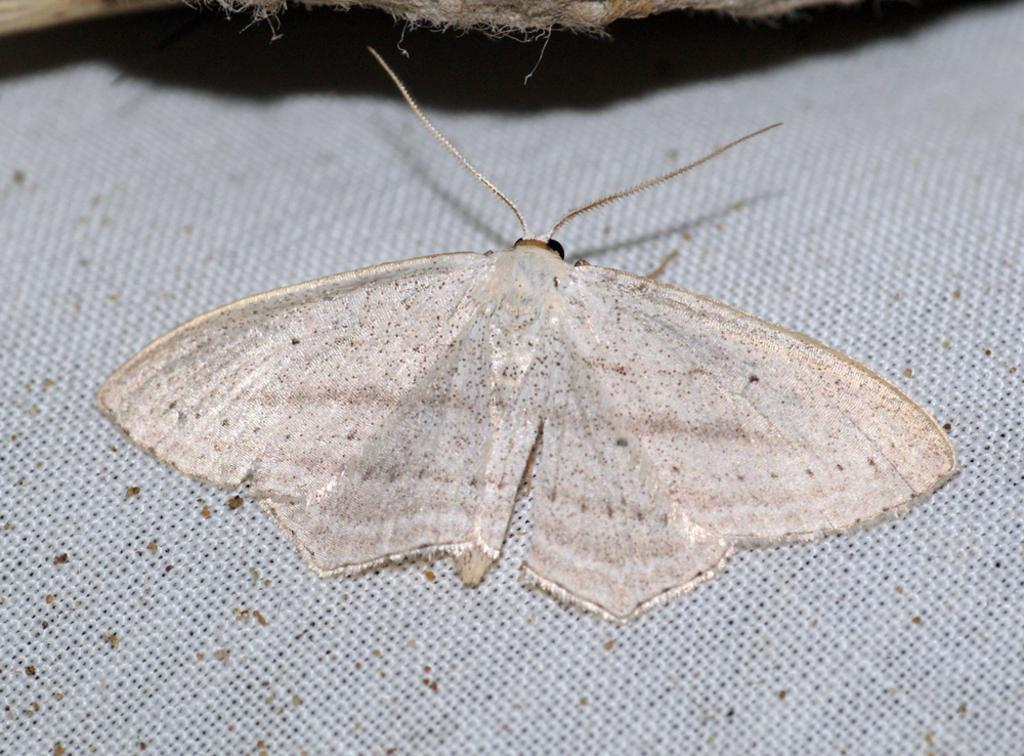What is located in the foreground of the image? There is an insect in the foreground of the image. What is the color of the bottom surface in the image? The bottom surface of the image is white. What type of son can be seen playing with a brick in the image? There is no son or brick present in the image; it only features an insect in the foreground and a white bottom surface. 